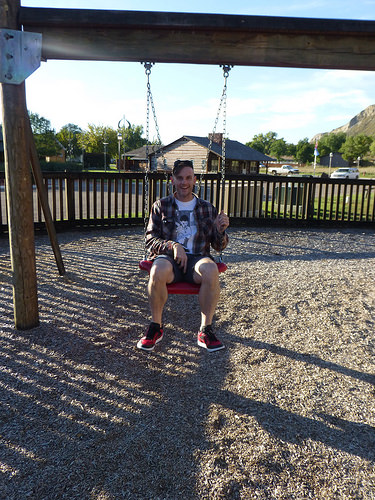<image>
Is the man on the swingset? Yes. Looking at the image, I can see the man is positioned on top of the swingset, with the swingset providing support. 